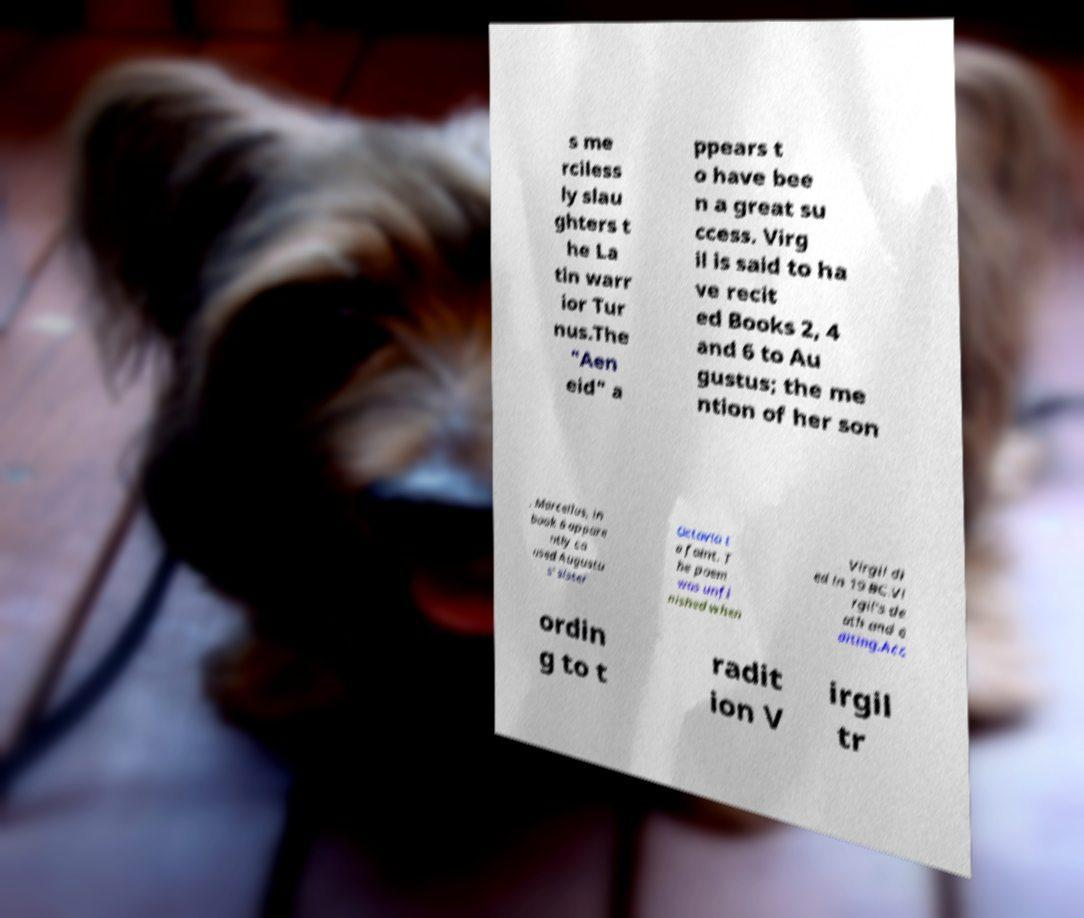There's text embedded in this image that I need extracted. Can you transcribe it verbatim? s me rciless ly slau ghters t he La tin warr ior Tur nus.The "Aen eid" a ppears t o have bee n a great su ccess. Virg il is said to ha ve recit ed Books 2, 4 and 6 to Au gustus; the me ntion of her son , Marcellus, in book 6 appare ntly ca used Augustu s' sister Octavia t o faint. T he poem was unfi nished when Virgil di ed in 19 BC.Vi rgil's de ath and e diting.Acc ordin g to t radit ion V irgil tr 